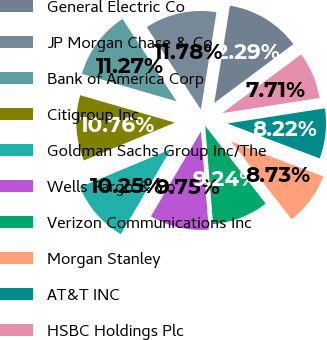Convert chart to OTSL. <chart><loc_0><loc_0><loc_500><loc_500><pie_chart><fcel>General Electric Co<fcel>JP Morgan Chase & Co<fcel>Bank of America Corp<fcel>Citigroup Inc<fcel>Goldman Sachs Group Inc/The<fcel>Wells Fargo & Co<fcel>Verizon Communications Inc<fcel>Morgan Stanley<fcel>AT&T INC<fcel>HSBC Holdings Plc<nl><fcel>12.29%<fcel>11.78%<fcel>11.27%<fcel>10.76%<fcel>10.25%<fcel>9.75%<fcel>9.24%<fcel>8.73%<fcel>8.22%<fcel>7.71%<nl></chart> 